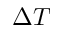Convert formula to latex. <formula><loc_0><loc_0><loc_500><loc_500>\Delta T</formula> 